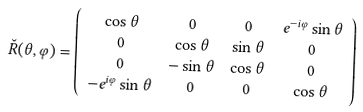Convert formula to latex. <formula><loc_0><loc_0><loc_500><loc_500>\breve { R } ( \theta , \varphi ) & = \left ( \begin{array} { c c c c } \cos \theta & 0 & 0 & e ^ { - i \varphi } \sin \theta \\ 0 & \cos \theta & \sin \theta & 0 \\ 0 & - \sin \theta & \cos \theta & 0 \\ - e ^ { i \varphi } \sin \theta & 0 & 0 & \cos \theta \end{array} \right )</formula> 